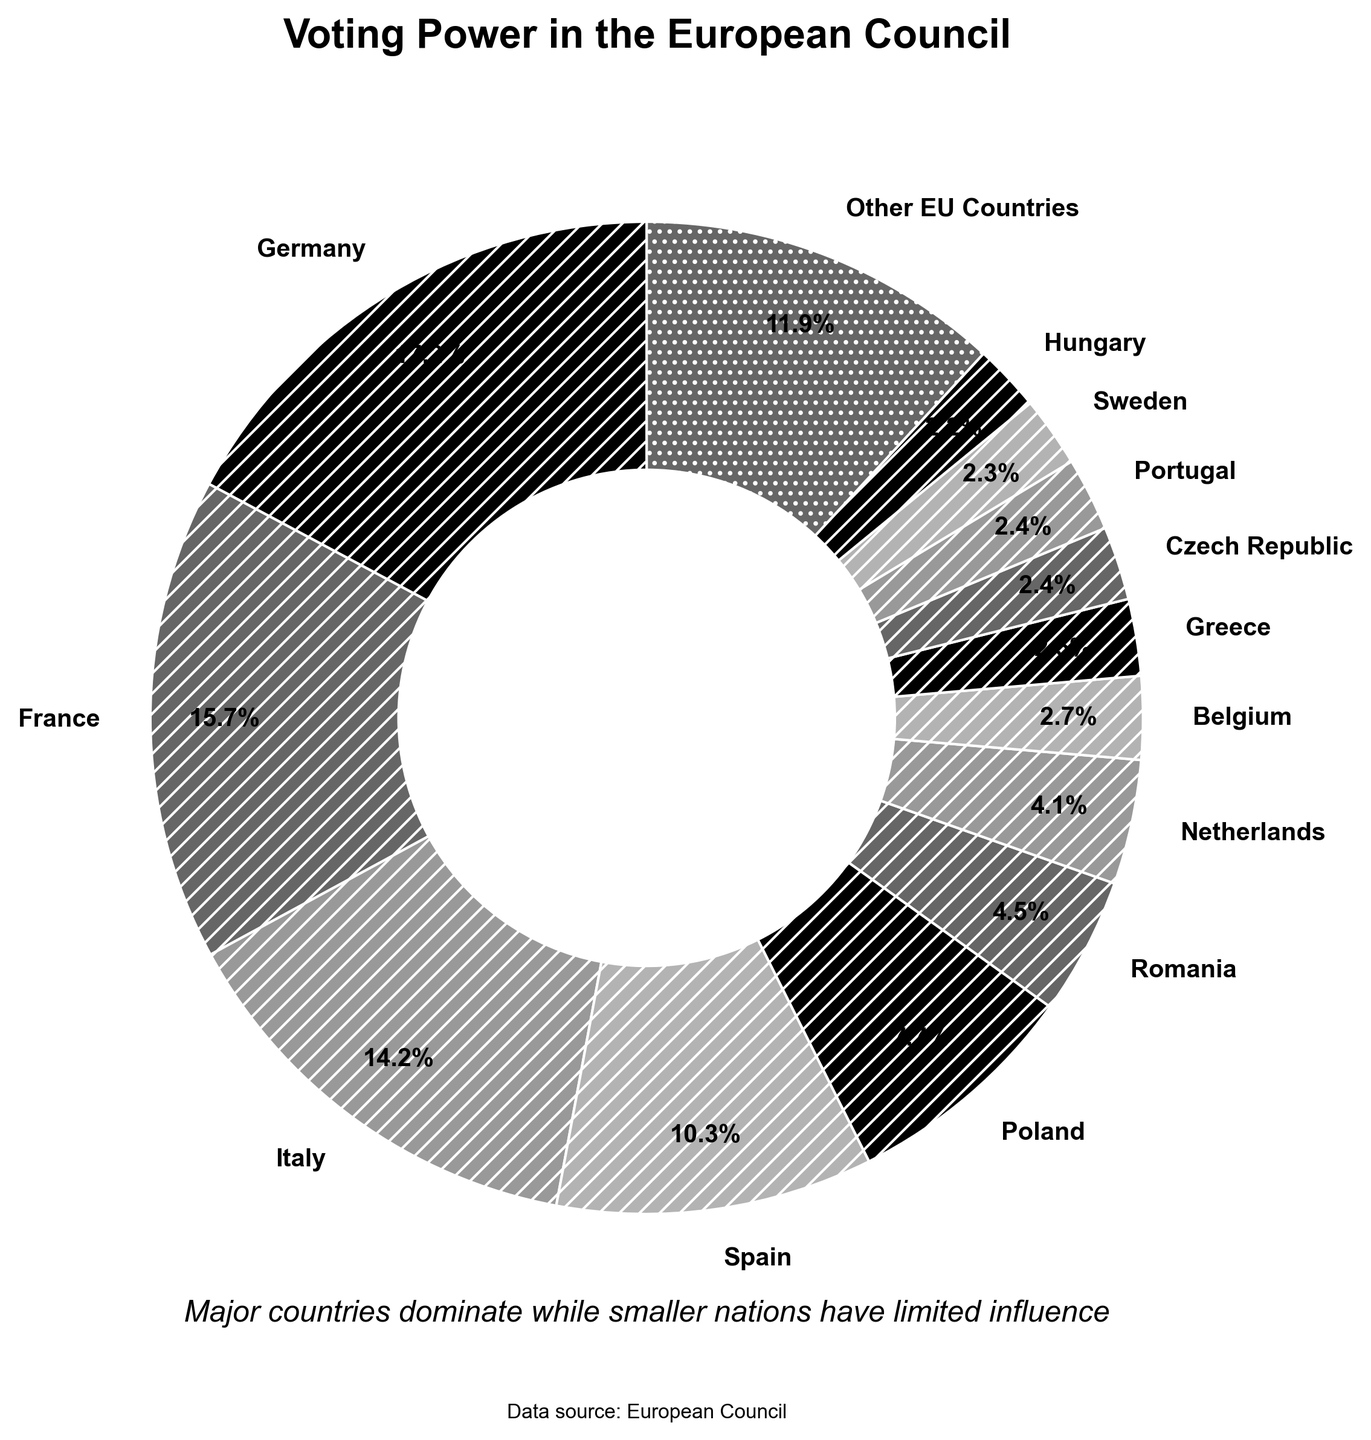Which country has the highest voting power in the European Council? By looking at the proportion of the pie chart, Germany has the largest wedge, indicating it has the highest voting power.
Answer: Germany What percentage of the total voting power is held by smaller EU countries combined? The smaller EU countries are grouped under "Other EU Countries" in the chart. Their combined voting power is directly labeled as a percentage on the pie chart.
Answer: 19.9% How many major countries have a voting power greater than 10%? By observing the pie chart, Germany, France, and Italy each have a voting power greater than 10%.
Answer: 3 By how much is Germany's voting power greater than Spain's? Germany's voting power is 16.5% and Spain's is 9.9%. The difference is calculated as 16.5 - 9.9 = 6.6%.
Answer: 6.6% Are there more countries with voting power above 2% or below 2%? The pie chart highlights countries with voting power above 2% individually and groups the rest as "Other EU Countries." Counting the labels, there are more countries below 2%.
Answer: Below 2% Which two countries have the closest voting power percentages to each other? On the pie chart, Portugal and Czech Republic each have a voting power of 2.3%, making them the closest in value.
Answer: Portugal and Czech Republic What is the total voting power percentage of Germany, France, and Italy combined? Germany has 16.5%, France has 15.1%, and Italy has 13.6%. The combined total is 16.5 + 15.1 + 13.6 = 45.2%.
Answer: 45.2% Which country has slightly more voting power, Belgium or Sweden? By comparing the wedges on the chart, Belgium has a voting power of 2.6%, slightly more than Sweden's 2.2%.
Answer: Belgium How does the voting power of the Netherlands compare to Romania's? In the pie chart, the Netherlands has a voting power of 3.9%, while Romania has 4.3%. Therefore, Romania has a slightly higher voting power than the Netherlands.
Answer: Romania What is the combined voting power of the three countries with the lowest individual percentages? The three countries with the lowest percentages are Malta (0.1%), Luxembourg (0.1%), and Cyprus (0.2%). Combined, their voting power is 0.1 + 0.1 + 0.2 = 0.4%.
Answer: 0.4% 